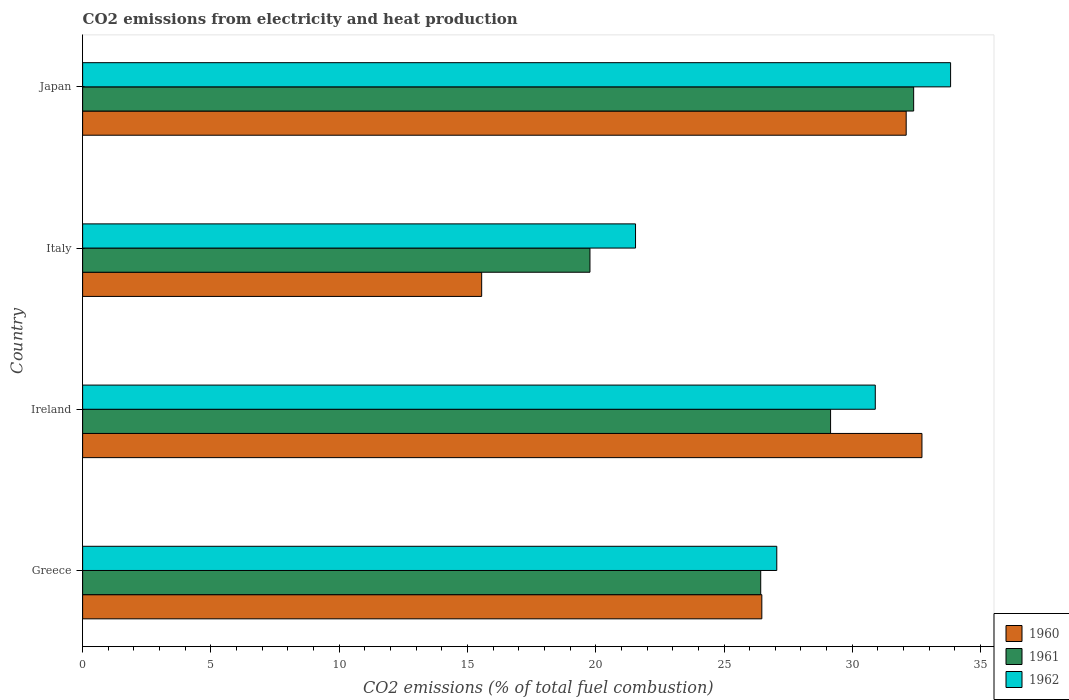How many groups of bars are there?
Make the answer very short. 4. Are the number of bars per tick equal to the number of legend labels?
Make the answer very short. Yes. How many bars are there on the 2nd tick from the top?
Keep it short and to the point. 3. How many bars are there on the 2nd tick from the bottom?
Your answer should be very brief. 3. What is the label of the 1st group of bars from the top?
Keep it short and to the point. Japan. In how many cases, is the number of bars for a given country not equal to the number of legend labels?
Provide a succinct answer. 0. What is the amount of CO2 emitted in 1960 in Ireland?
Your response must be concise. 32.72. Across all countries, what is the maximum amount of CO2 emitted in 1962?
Keep it short and to the point. 33.83. Across all countries, what is the minimum amount of CO2 emitted in 1962?
Make the answer very short. 21.55. What is the total amount of CO2 emitted in 1961 in the graph?
Give a very brief answer. 107.75. What is the difference between the amount of CO2 emitted in 1962 in Italy and that in Japan?
Keep it short and to the point. -12.28. What is the difference between the amount of CO2 emitted in 1962 in Italy and the amount of CO2 emitted in 1960 in Ireland?
Provide a succinct answer. -11.16. What is the average amount of CO2 emitted in 1961 per country?
Offer a terse response. 26.94. What is the difference between the amount of CO2 emitted in 1960 and amount of CO2 emitted in 1961 in Italy?
Ensure brevity in your answer.  -4.22. In how many countries, is the amount of CO2 emitted in 1962 greater than 8 %?
Your response must be concise. 4. What is the ratio of the amount of CO2 emitted in 1962 in Ireland to that in Italy?
Give a very brief answer. 1.43. What is the difference between the highest and the second highest amount of CO2 emitted in 1961?
Give a very brief answer. 3.24. What is the difference between the highest and the lowest amount of CO2 emitted in 1962?
Offer a terse response. 12.28. In how many countries, is the amount of CO2 emitted in 1961 greater than the average amount of CO2 emitted in 1961 taken over all countries?
Your answer should be very brief. 2. Are all the bars in the graph horizontal?
Ensure brevity in your answer.  Yes. Does the graph contain grids?
Your answer should be compact. No. Where does the legend appear in the graph?
Offer a terse response. Bottom right. How many legend labels are there?
Make the answer very short. 3. How are the legend labels stacked?
Ensure brevity in your answer.  Vertical. What is the title of the graph?
Offer a terse response. CO2 emissions from electricity and heat production. Does "1992" appear as one of the legend labels in the graph?
Offer a very short reply. No. What is the label or title of the X-axis?
Ensure brevity in your answer.  CO2 emissions (% of total fuel combustion). What is the CO2 emissions (% of total fuel combustion) of 1960 in Greece?
Make the answer very short. 26.47. What is the CO2 emissions (% of total fuel combustion) in 1961 in Greece?
Your response must be concise. 26.43. What is the CO2 emissions (% of total fuel combustion) of 1962 in Greece?
Ensure brevity in your answer.  27.06. What is the CO2 emissions (% of total fuel combustion) in 1960 in Ireland?
Give a very brief answer. 32.72. What is the CO2 emissions (% of total fuel combustion) of 1961 in Ireland?
Give a very brief answer. 29.15. What is the CO2 emissions (% of total fuel combustion) in 1962 in Ireland?
Make the answer very short. 30.9. What is the CO2 emissions (% of total fuel combustion) of 1960 in Italy?
Provide a short and direct response. 15.55. What is the CO2 emissions (% of total fuel combustion) of 1961 in Italy?
Your answer should be compact. 19.78. What is the CO2 emissions (% of total fuel combustion) in 1962 in Italy?
Offer a terse response. 21.55. What is the CO2 emissions (% of total fuel combustion) in 1960 in Japan?
Keep it short and to the point. 32.1. What is the CO2 emissions (% of total fuel combustion) in 1961 in Japan?
Keep it short and to the point. 32.39. What is the CO2 emissions (% of total fuel combustion) of 1962 in Japan?
Offer a terse response. 33.83. Across all countries, what is the maximum CO2 emissions (% of total fuel combustion) of 1960?
Your response must be concise. 32.72. Across all countries, what is the maximum CO2 emissions (% of total fuel combustion) of 1961?
Give a very brief answer. 32.39. Across all countries, what is the maximum CO2 emissions (% of total fuel combustion) of 1962?
Your response must be concise. 33.83. Across all countries, what is the minimum CO2 emissions (% of total fuel combustion) of 1960?
Offer a very short reply. 15.55. Across all countries, what is the minimum CO2 emissions (% of total fuel combustion) of 1961?
Make the answer very short. 19.78. Across all countries, what is the minimum CO2 emissions (% of total fuel combustion) of 1962?
Ensure brevity in your answer.  21.55. What is the total CO2 emissions (% of total fuel combustion) of 1960 in the graph?
Provide a succinct answer. 106.85. What is the total CO2 emissions (% of total fuel combustion) of 1961 in the graph?
Give a very brief answer. 107.75. What is the total CO2 emissions (% of total fuel combustion) of 1962 in the graph?
Offer a very short reply. 113.34. What is the difference between the CO2 emissions (% of total fuel combustion) in 1960 in Greece and that in Ireland?
Keep it short and to the point. -6.24. What is the difference between the CO2 emissions (% of total fuel combustion) of 1961 in Greece and that in Ireland?
Provide a short and direct response. -2.72. What is the difference between the CO2 emissions (% of total fuel combustion) of 1962 in Greece and that in Ireland?
Offer a terse response. -3.84. What is the difference between the CO2 emissions (% of total fuel combustion) of 1960 in Greece and that in Italy?
Provide a succinct answer. 10.92. What is the difference between the CO2 emissions (% of total fuel combustion) in 1961 in Greece and that in Italy?
Provide a short and direct response. 6.66. What is the difference between the CO2 emissions (% of total fuel combustion) in 1962 in Greece and that in Italy?
Offer a very short reply. 5.51. What is the difference between the CO2 emissions (% of total fuel combustion) of 1960 in Greece and that in Japan?
Your answer should be very brief. -5.63. What is the difference between the CO2 emissions (% of total fuel combustion) in 1961 in Greece and that in Japan?
Offer a very short reply. -5.96. What is the difference between the CO2 emissions (% of total fuel combustion) in 1962 in Greece and that in Japan?
Provide a succinct answer. -6.78. What is the difference between the CO2 emissions (% of total fuel combustion) in 1960 in Ireland and that in Italy?
Your response must be concise. 17.16. What is the difference between the CO2 emissions (% of total fuel combustion) in 1961 in Ireland and that in Italy?
Provide a short and direct response. 9.38. What is the difference between the CO2 emissions (% of total fuel combustion) in 1962 in Ireland and that in Italy?
Provide a short and direct response. 9.35. What is the difference between the CO2 emissions (% of total fuel combustion) of 1960 in Ireland and that in Japan?
Make the answer very short. 0.61. What is the difference between the CO2 emissions (% of total fuel combustion) of 1961 in Ireland and that in Japan?
Give a very brief answer. -3.24. What is the difference between the CO2 emissions (% of total fuel combustion) in 1962 in Ireland and that in Japan?
Provide a short and direct response. -2.94. What is the difference between the CO2 emissions (% of total fuel combustion) in 1960 in Italy and that in Japan?
Your answer should be compact. -16.55. What is the difference between the CO2 emissions (% of total fuel combustion) in 1961 in Italy and that in Japan?
Give a very brief answer. -12.62. What is the difference between the CO2 emissions (% of total fuel combustion) in 1962 in Italy and that in Japan?
Keep it short and to the point. -12.28. What is the difference between the CO2 emissions (% of total fuel combustion) in 1960 in Greece and the CO2 emissions (% of total fuel combustion) in 1961 in Ireland?
Offer a terse response. -2.68. What is the difference between the CO2 emissions (% of total fuel combustion) of 1960 in Greece and the CO2 emissions (% of total fuel combustion) of 1962 in Ireland?
Your answer should be very brief. -4.42. What is the difference between the CO2 emissions (% of total fuel combustion) of 1961 in Greece and the CO2 emissions (% of total fuel combustion) of 1962 in Ireland?
Give a very brief answer. -4.47. What is the difference between the CO2 emissions (% of total fuel combustion) in 1960 in Greece and the CO2 emissions (% of total fuel combustion) in 1961 in Italy?
Make the answer very short. 6.7. What is the difference between the CO2 emissions (% of total fuel combustion) of 1960 in Greece and the CO2 emissions (% of total fuel combustion) of 1962 in Italy?
Offer a terse response. 4.92. What is the difference between the CO2 emissions (% of total fuel combustion) of 1961 in Greece and the CO2 emissions (% of total fuel combustion) of 1962 in Italy?
Keep it short and to the point. 4.88. What is the difference between the CO2 emissions (% of total fuel combustion) of 1960 in Greece and the CO2 emissions (% of total fuel combustion) of 1961 in Japan?
Provide a short and direct response. -5.92. What is the difference between the CO2 emissions (% of total fuel combustion) of 1960 in Greece and the CO2 emissions (% of total fuel combustion) of 1962 in Japan?
Offer a very short reply. -7.36. What is the difference between the CO2 emissions (% of total fuel combustion) in 1961 in Greece and the CO2 emissions (% of total fuel combustion) in 1962 in Japan?
Provide a succinct answer. -7.4. What is the difference between the CO2 emissions (% of total fuel combustion) of 1960 in Ireland and the CO2 emissions (% of total fuel combustion) of 1961 in Italy?
Offer a very short reply. 12.94. What is the difference between the CO2 emissions (% of total fuel combustion) of 1960 in Ireland and the CO2 emissions (% of total fuel combustion) of 1962 in Italy?
Ensure brevity in your answer.  11.16. What is the difference between the CO2 emissions (% of total fuel combustion) of 1961 in Ireland and the CO2 emissions (% of total fuel combustion) of 1962 in Italy?
Provide a succinct answer. 7.6. What is the difference between the CO2 emissions (% of total fuel combustion) in 1960 in Ireland and the CO2 emissions (% of total fuel combustion) in 1961 in Japan?
Your answer should be compact. 0.32. What is the difference between the CO2 emissions (% of total fuel combustion) of 1960 in Ireland and the CO2 emissions (% of total fuel combustion) of 1962 in Japan?
Offer a very short reply. -1.12. What is the difference between the CO2 emissions (% of total fuel combustion) of 1961 in Ireland and the CO2 emissions (% of total fuel combustion) of 1962 in Japan?
Offer a very short reply. -4.68. What is the difference between the CO2 emissions (% of total fuel combustion) in 1960 in Italy and the CO2 emissions (% of total fuel combustion) in 1961 in Japan?
Provide a succinct answer. -16.84. What is the difference between the CO2 emissions (% of total fuel combustion) of 1960 in Italy and the CO2 emissions (% of total fuel combustion) of 1962 in Japan?
Offer a very short reply. -18.28. What is the difference between the CO2 emissions (% of total fuel combustion) of 1961 in Italy and the CO2 emissions (% of total fuel combustion) of 1962 in Japan?
Provide a short and direct response. -14.06. What is the average CO2 emissions (% of total fuel combustion) in 1960 per country?
Provide a succinct answer. 26.71. What is the average CO2 emissions (% of total fuel combustion) of 1961 per country?
Make the answer very short. 26.94. What is the average CO2 emissions (% of total fuel combustion) of 1962 per country?
Make the answer very short. 28.33. What is the difference between the CO2 emissions (% of total fuel combustion) of 1960 and CO2 emissions (% of total fuel combustion) of 1961 in Greece?
Provide a short and direct response. 0.04. What is the difference between the CO2 emissions (% of total fuel combustion) of 1960 and CO2 emissions (% of total fuel combustion) of 1962 in Greece?
Provide a short and direct response. -0.58. What is the difference between the CO2 emissions (% of total fuel combustion) of 1961 and CO2 emissions (% of total fuel combustion) of 1962 in Greece?
Provide a succinct answer. -0.63. What is the difference between the CO2 emissions (% of total fuel combustion) of 1960 and CO2 emissions (% of total fuel combustion) of 1961 in Ireland?
Your response must be concise. 3.56. What is the difference between the CO2 emissions (% of total fuel combustion) in 1960 and CO2 emissions (% of total fuel combustion) in 1962 in Ireland?
Offer a very short reply. 1.82. What is the difference between the CO2 emissions (% of total fuel combustion) in 1961 and CO2 emissions (% of total fuel combustion) in 1962 in Ireland?
Provide a short and direct response. -1.74. What is the difference between the CO2 emissions (% of total fuel combustion) in 1960 and CO2 emissions (% of total fuel combustion) in 1961 in Italy?
Provide a short and direct response. -4.22. What is the difference between the CO2 emissions (% of total fuel combustion) of 1960 and CO2 emissions (% of total fuel combustion) of 1962 in Italy?
Make the answer very short. -6. What is the difference between the CO2 emissions (% of total fuel combustion) in 1961 and CO2 emissions (% of total fuel combustion) in 1962 in Italy?
Provide a short and direct response. -1.78. What is the difference between the CO2 emissions (% of total fuel combustion) in 1960 and CO2 emissions (% of total fuel combustion) in 1961 in Japan?
Offer a terse response. -0.29. What is the difference between the CO2 emissions (% of total fuel combustion) of 1960 and CO2 emissions (% of total fuel combustion) of 1962 in Japan?
Give a very brief answer. -1.73. What is the difference between the CO2 emissions (% of total fuel combustion) in 1961 and CO2 emissions (% of total fuel combustion) in 1962 in Japan?
Provide a succinct answer. -1.44. What is the ratio of the CO2 emissions (% of total fuel combustion) in 1960 in Greece to that in Ireland?
Ensure brevity in your answer.  0.81. What is the ratio of the CO2 emissions (% of total fuel combustion) of 1961 in Greece to that in Ireland?
Provide a short and direct response. 0.91. What is the ratio of the CO2 emissions (% of total fuel combustion) of 1962 in Greece to that in Ireland?
Your response must be concise. 0.88. What is the ratio of the CO2 emissions (% of total fuel combustion) in 1960 in Greece to that in Italy?
Give a very brief answer. 1.7. What is the ratio of the CO2 emissions (% of total fuel combustion) in 1961 in Greece to that in Italy?
Your response must be concise. 1.34. What is the ratio of the CO2 emissions (% of total fuel combustion) in 1962 in Greece to that in Italy?
Your response must be concise. 1.26. What is the ratio of the CO2 emissions (% of total fuel combustion) of 1960 in Greece to that in Japan?
Provide a short and direct response. 0.82. What is the ratio of the CO2 emissions (% of total fuel combustion) in 1961 in Greece to that in Japan?
Provide a short and direct response. 0.82. What is the ratio of the CO2 emissions (% of total fuel combustion) in 1962 in Greece to that in Japan?
Provide a short and direct response. 0.8. What is the ratio of the CO2 emissions (% of total fuel combustion) in 1960 in Ireland to that in Italy?
Provide a succinct answer. 2.1. What is the ratio of the CO2 emissions (% of total fuel combustion) of 1961 in Ireland to that in Italy?
Provide a short and direct response. 1.47. What is the ratio of the CO2 emissions (% of total fuel combustion) in 1962 in Ireland to that in Italy?
Keep it short and to the point. 1.43. What is the ratio of the CO2 emissions (% of total fuel combustion) of 1960 in Ireland to that in Japan?
Offer a terse response. 1.02. What is the ratio of the CO2 emissions (% of total fuel combustion) in 1962 in Ireland to that in Japan?
Your answer should be compact. 0.91. What is the ratio of the CO2 emissions (% of total fuel combustion) in 1960 in Italy to that in Japan?
Make the answer very short. 0.48. What is the ratio of the CO2 emissions (% of total fuel combustion) of 1961 in Italy to that in Japan?
Your answer should be very brief. 0.61. What is the ratio of the CO2 emissions (% of total fuel combustion) in 1962 in Italy to that in Japan?
Give a very brief answer. 0.64. What is the difference between the highest and the second highest CO2 emissions (% of total fuel combustion) in 1960?
Provide a succinct answer. 0.61. What is the difference between the highest and the second highest CO2 emissions (% of total fuel combustion) in 1961?
Your answer should be very brief. 3.24. What is the difference between the highest and the second highest CO2 emissions (% of total fuel combustion) in 1962?
Give a very brief answer. 2.94. What is the difference between the highest and the lowest CO2 emissions (% of total fuel combustion) of 1960?
Provide a short and direct response. 17.16. What is the difference between the highest and the lowest CO2 emissions (% of total fuel combustion) in 1961?
Give a very brief answer. 12.62. What is the difference between the highest and the lowest CO2 emissions (% of total fuel combustion) of 1962?
Provide a succinct answer. 12.28. 